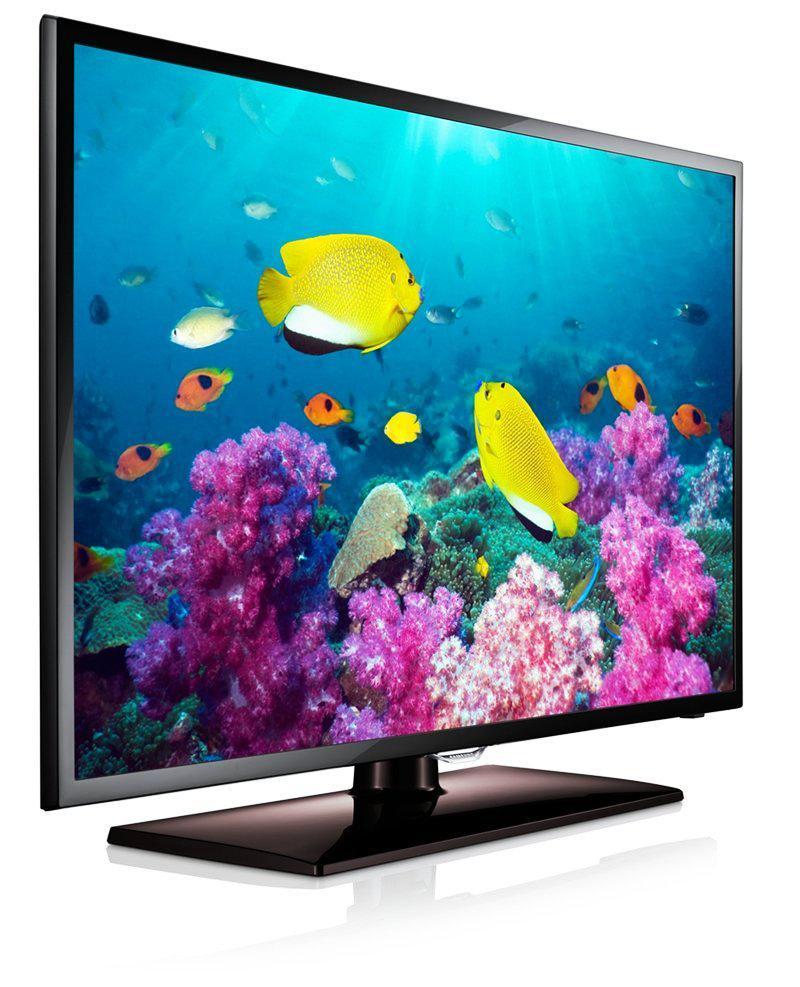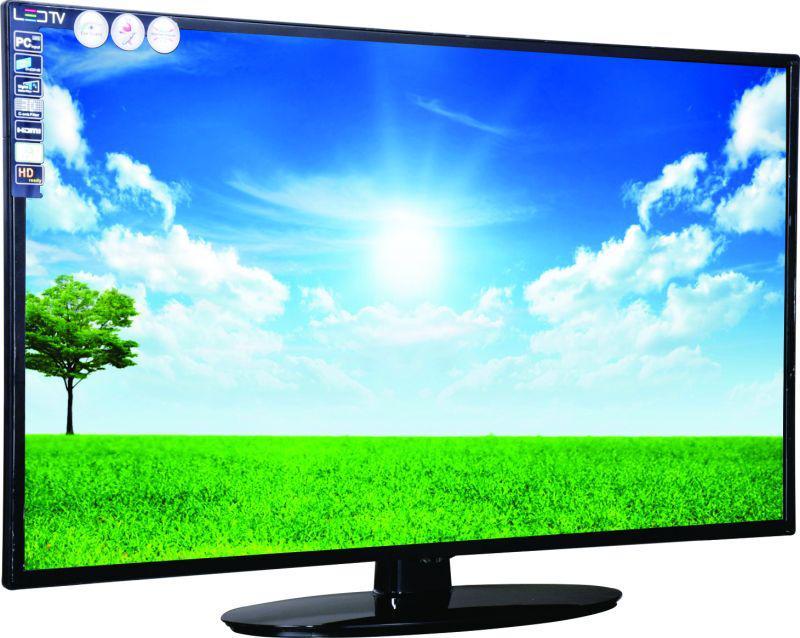The first image is the image on the left, the second image is the image on the right. For the images displayed, is the sentence "Both monitors have one leg." factually correct? Answer yes or no. Yes. 